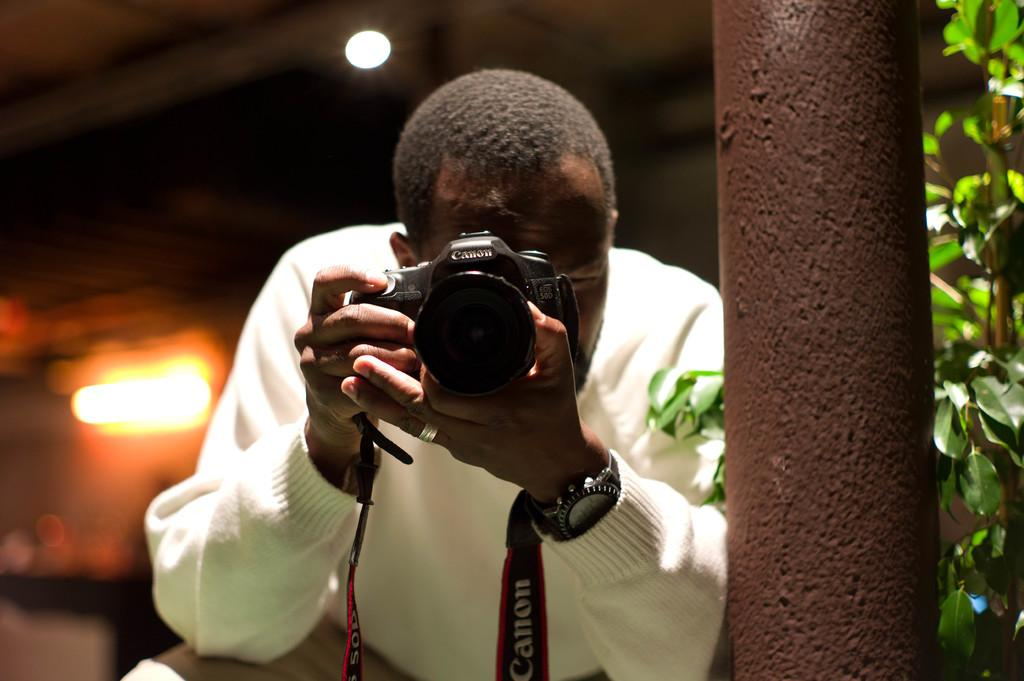Who is the main subject in the image? There is a man in the image. What is the man holding in the image? The man is holding a camera. What accessory is the man wearing in the image? The man has a watch on his arm. What can be seen in the background of the image? There is a plant and a light in the background of the image. What type of wool can be seen in the image? There is no wool present in the image. What view can be seen from the sidewalk in the image? There is no sidewalk present in the image. 